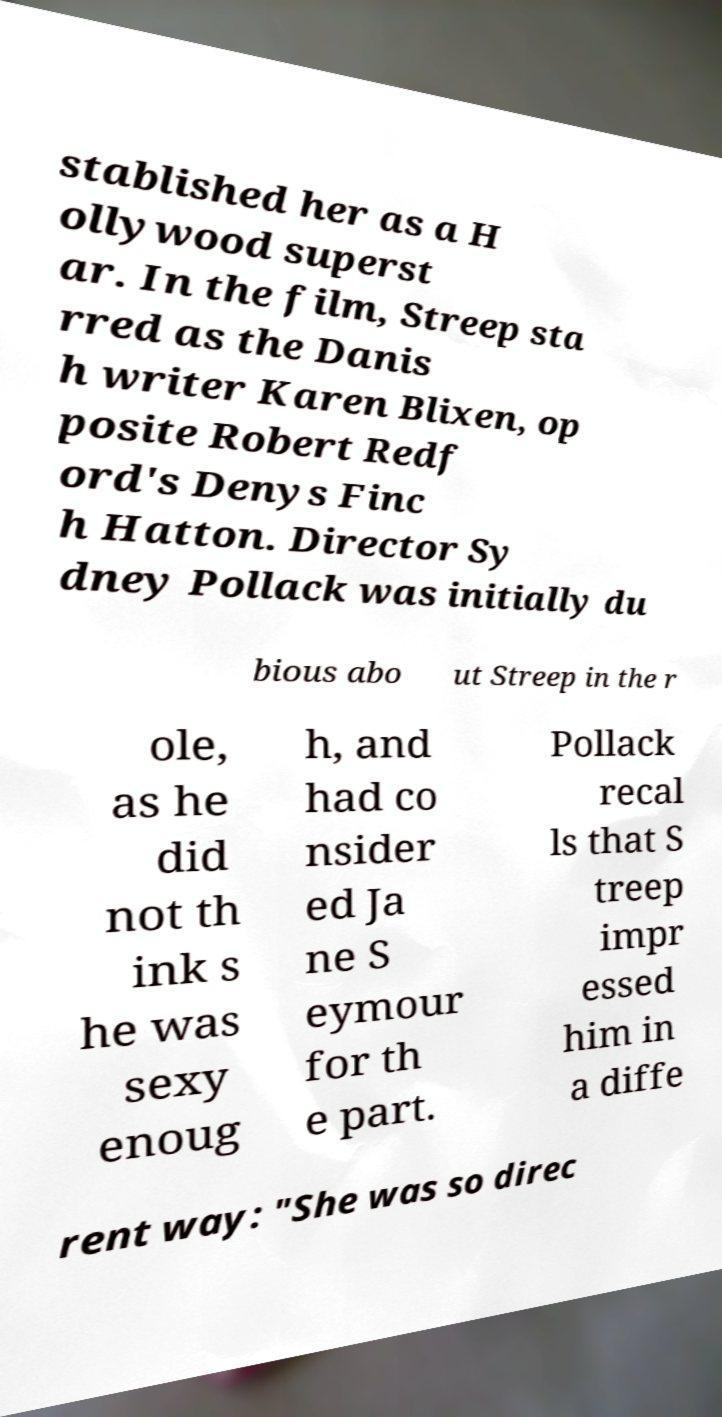I need the written content from this picture converted into text. Can you do that? stablished her as a H ollywood superst ar. In the film, Streep sta rred as the Danis h writer Karen Blixen, op posite Robert Redf ord's Denys Finc h Hatton. Director Sy dney Pollack was initially du bious abo ut Streep in the r ole, as he did not th ink s he was sexy enoug h, and had co nsider ed Ja ne S eymour for th e part. Pollack recal ls that S treep impr essed him in a diffe rent way: "She was so direc 